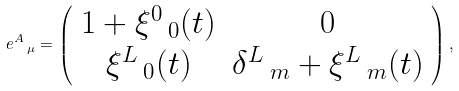Convert formula to latex. <formula><loc_0><loc_0><loc_500><loc_500>e ^ { A } \, _ { \mu } = \left ( \begin{array} { c c } 1 + \xi ^ { 0 } \, _ { 0 } ( t ) & 0 \\ \xi ^ { L } \, _ { 0 } ( t ) & \delta ^ { L } \, _ { m } + \xi ^ { L } \, _ { m } ( t ) \end{array} \right ) ,</formula> 